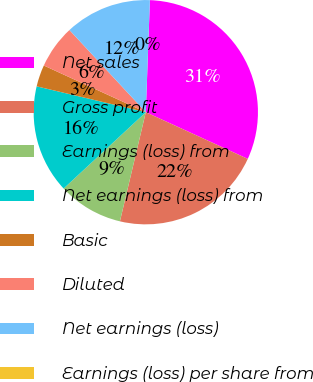Convert chart. <chart><loc_0><loc_0><loc_500><loc_500><pie_chart><fcel>Net sales<fcel>Gross profit<fcel>Earnings (loss) from<fcel>Net earnings (loss) from<fcel>Basic<fcel>Diluted<fcel>Net earnings (loss)<fcel>Earnings (loss) per share from<nl><fcel>31.25%<fcel>21.87%<fcel>9.38%<fcel>15.62%<fcel>3.13%<fcel>6.25%<fcel>12.5%<fcel>0.0%<nl></chart> 